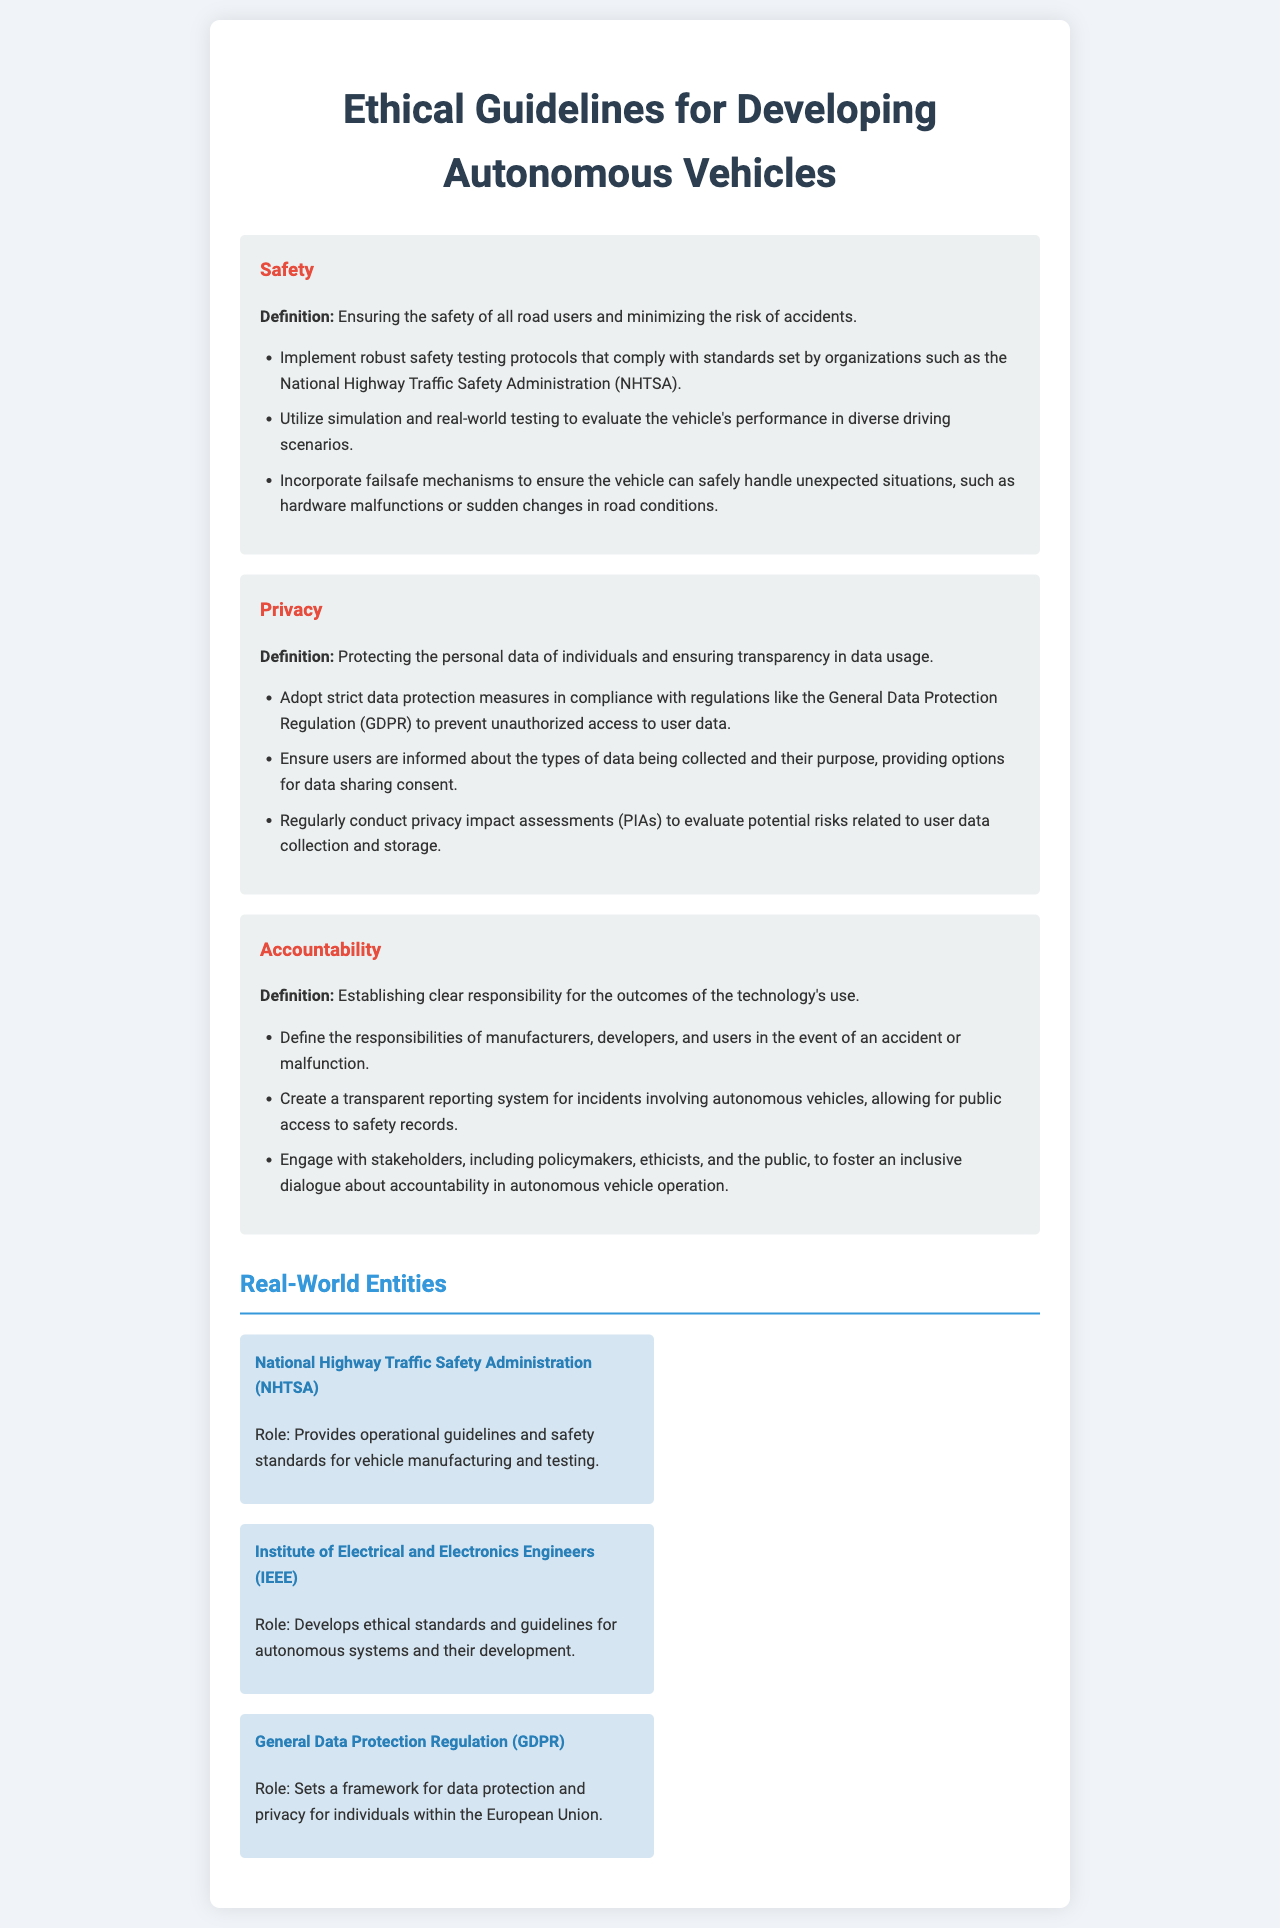What are the three focus areas in the document? The document outlines three focus areas for ethical guidelines: Safety, Privacy, and Accountability.
Answer: Safety, Privacy, Accountability What organization sets a framework for data protection and privacy within the European Union? The General Data Protection Regulation (GDPR) establishes data protection frameworks in the EU.
Answer: General Data Protection Regulation (GDPR) What mechanism is suggested to handle unexpected vehicle situations? The guidelines recommend incorporating failsafe mechanisms to ensure safe handling of unexpected incidents.
Answer: Failsafe mechanisms What is one responsibility defined for manufacturers in the case of an accident? The document specifies that manufacturers should have defined responsibilities regarding accidents or malfunctions of autonomous vehicles.
Answer: Defined responsibilities What is the role of the National Highway Traffic Safety Administration (NHTSA)? The NHTSA provides operational guidelines and safety standards for vehicle manufacturing and testing.
Answer: Provides operational guidelines and safety standards What type of assessments should be regularly conducted to evaluate user data risks? Privacy impact assessments (PIAs) should be regularly conducted to assess risks related to user data collection and storage.
Answer: Privacy impact assessments (PIAs) How should accountability in autonomous vehicle operation be fostered? The document suggests engaging with stakeholders, including policymakers and the public, to foster an inclusive dialogue on accountability.
Answer: Engaging with stakeholders What testing protocols are recommended for safety? Robust safety testing protocols that comply with standards set by organizations such as NHTSA are recommended.
Answer: Robust safety testing protocols 